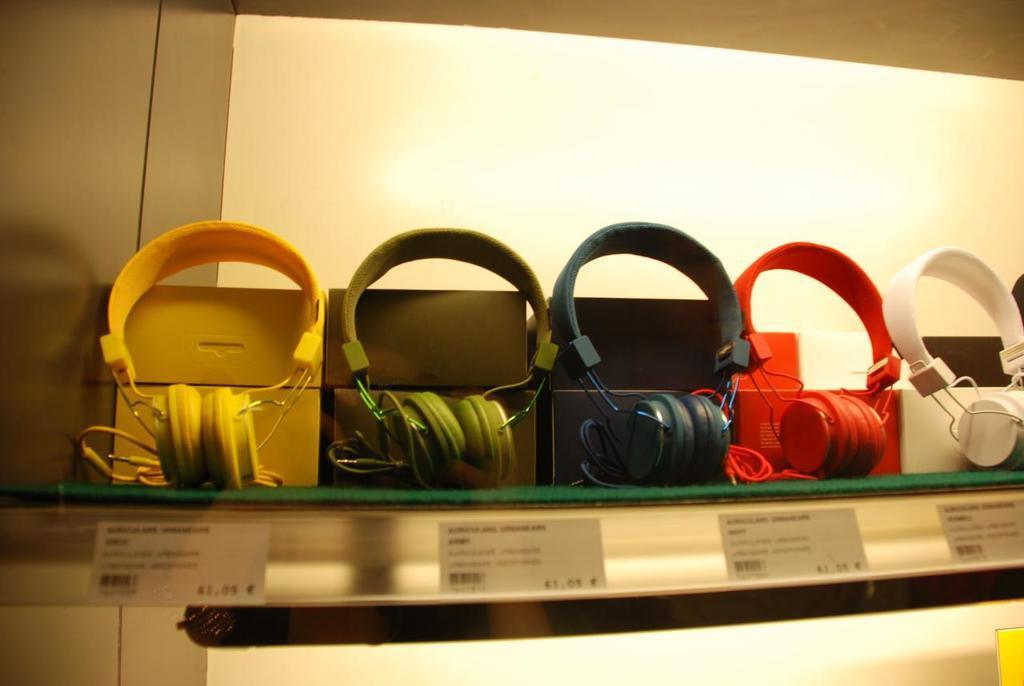Please provide a concise description of this image. In this image there are different colored headphones on display with price tags. 